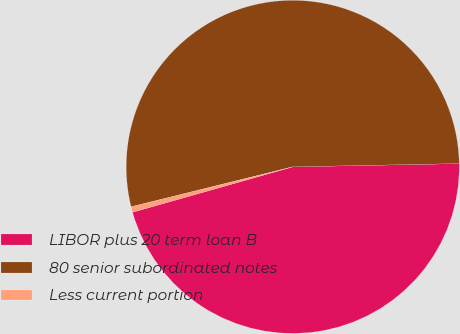Convert chart to OTSL. <chart><loc_0><loc_0><loc_500><loc_500><pie_chart><fcel>LIBOR plus 20 term loan B<fcel>80 senior subordinated notes<fcel>Less current portion<nl><fcel>45.92%<fcel>53.55%<fcel>0.54%<nl></chart> 